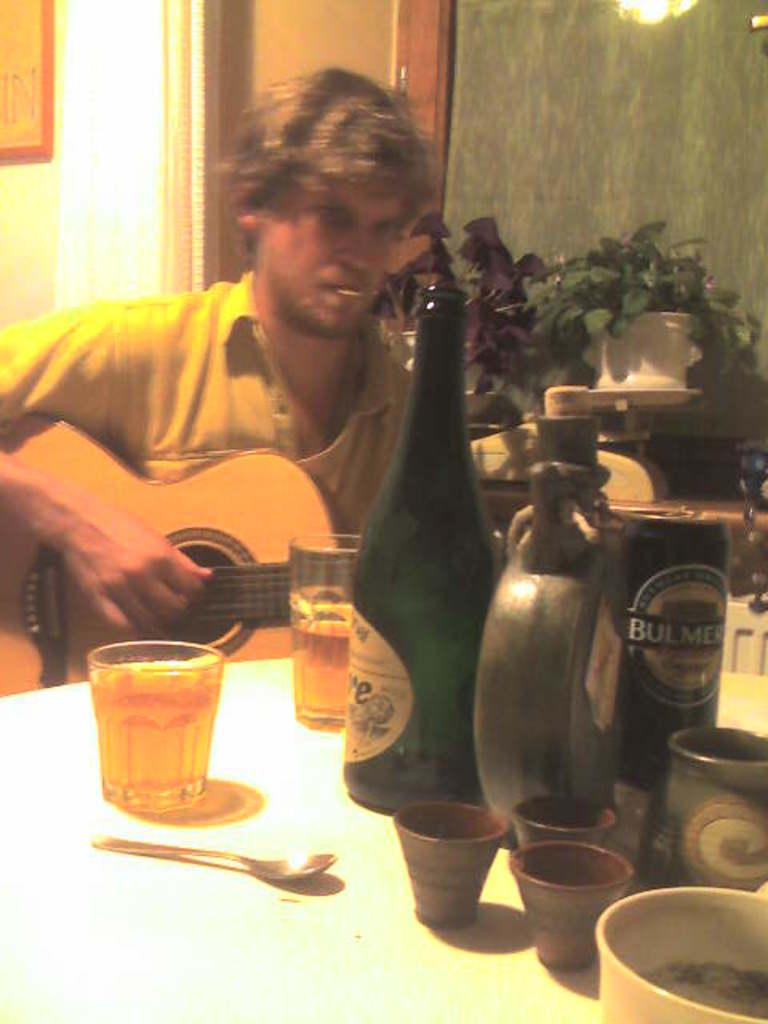<image>
Relay a brief, clear account of the picture shown. a man next to a bottle that has the letter E on it 